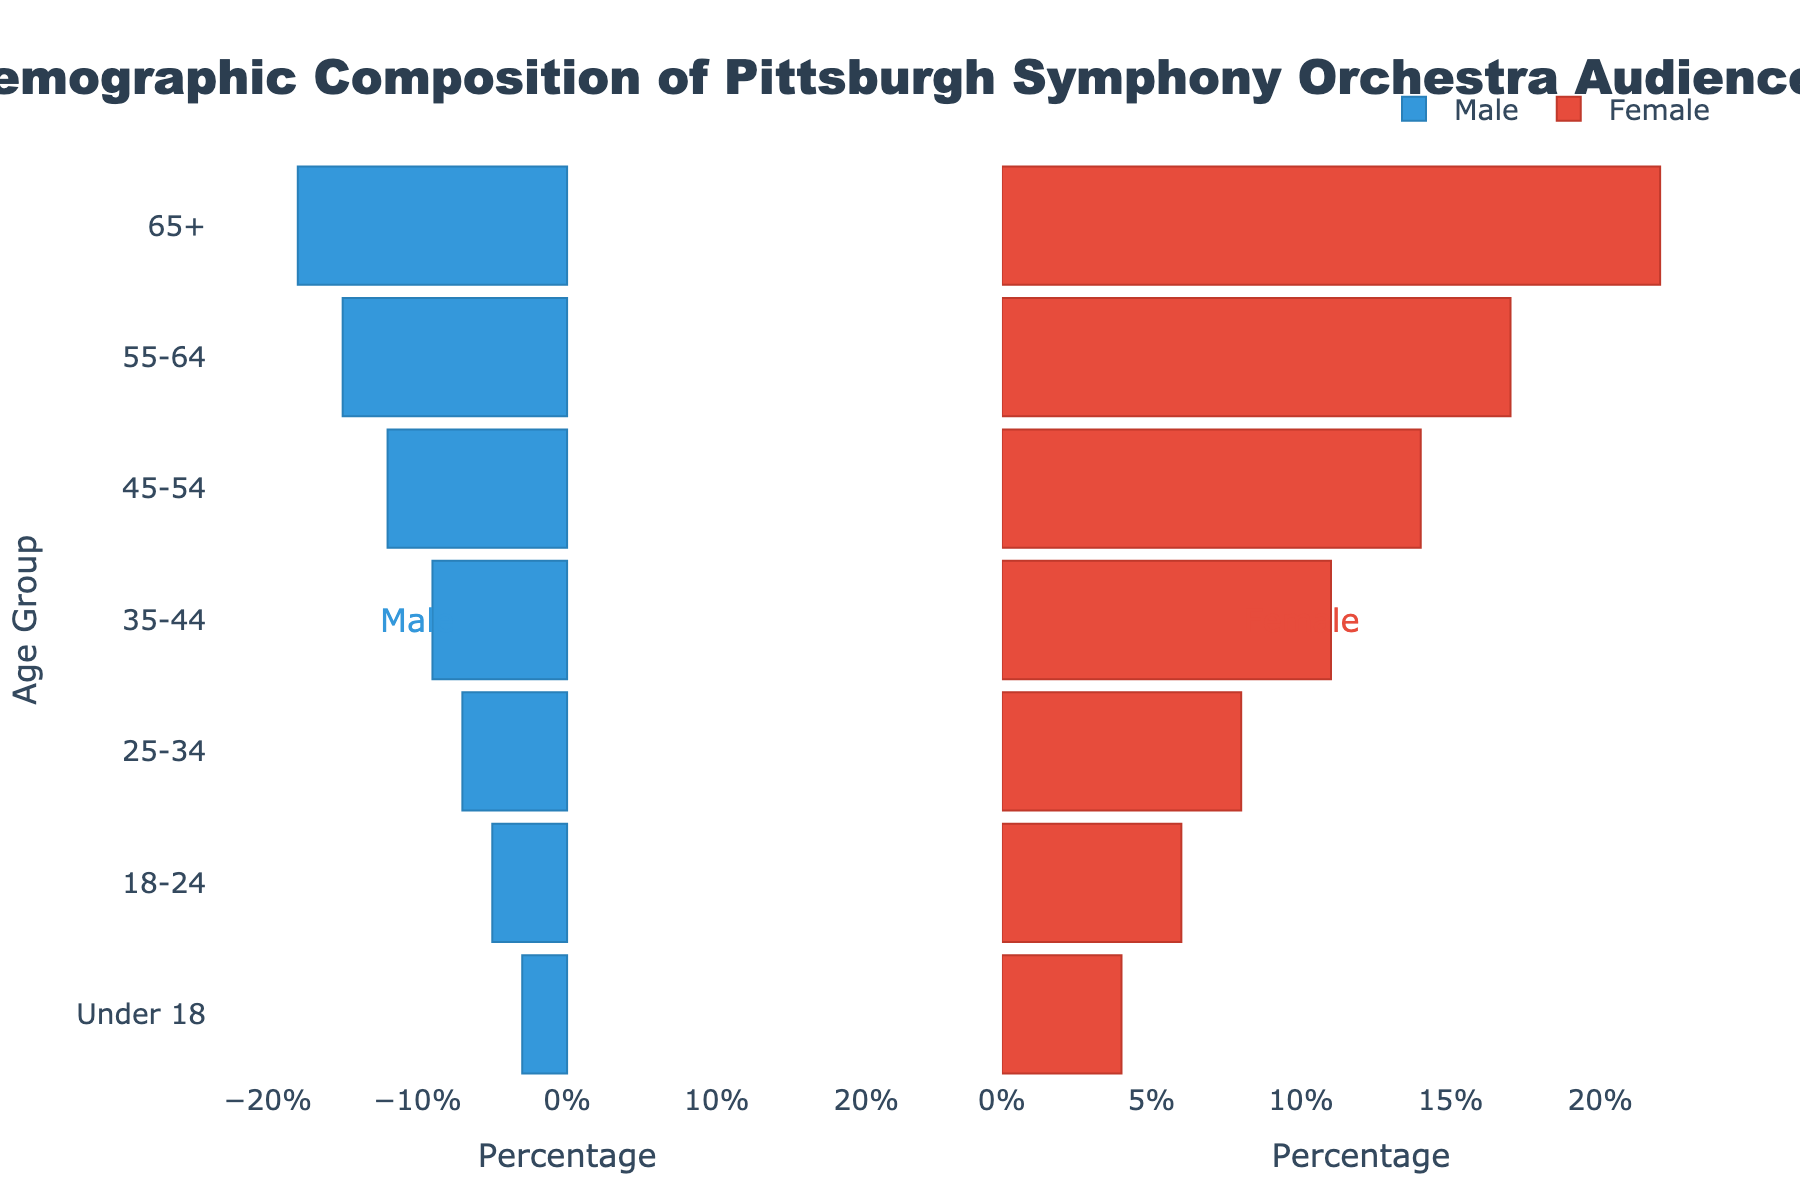Which age group has the highest number of female attendees? Look at the bar for each age group on the right side of the pyramid, note the highest value for female attendees. The 65+ age group has the highest bar.
Answer: 65+ What's the difference in the number of male attendees between the age groups 45-54 and 18-24? Identify the number of male attendees for the age groups 45-54 (12) and 18-24 (5). Subtract the smaller from the larger (12 - 5).
Answer: 7 What is the total number of male attendees in the age groups 55-64 and 65+? Add the numbers of male attendees for age groups 55-64 (15) and 65+ (18).
Answer: 33 Which gender has more attendees in the 35-44 age group? Compare the bars representing male (9) and female (11) attendees in the 35-44 age group. The female bar is higher.
Answer: Female Which age group has the lowest number of male attendees? Look for the age group with the smallest bar on the left side of the pyramid (Male). The "Under 18" age group has the smallest bar (3).
Answer: Under 18 What is the male-to-female ratio in the 25-34 age group? Identify the number of male attendees (7) and female attendees (8) in the 25-34 age group and calculate the ratio of male to female (7/8).
Answer: 7:8 How many more female attendees are there compared to male attendees in the 18-24 age group? Identify the number of female attendees (6) and male attendees (5) in the 18-24 age group, then subtract the number of male attendees from the number of female attendees (6 - 5).
Answer: 1 Which age group has the closest number of male and female attendees? Compare the male and female bars for each age group to find the one with the smallest difference. The 25-34 age group has males (7) and females (8), which is the smallest difference of 1.
Answer: 25-34 